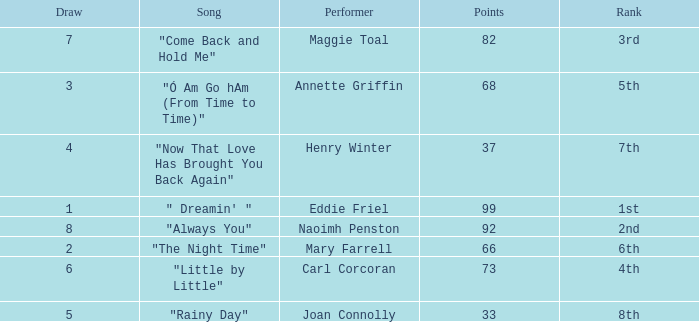What is the lowest points when the ranking is 1st? 99.0. 